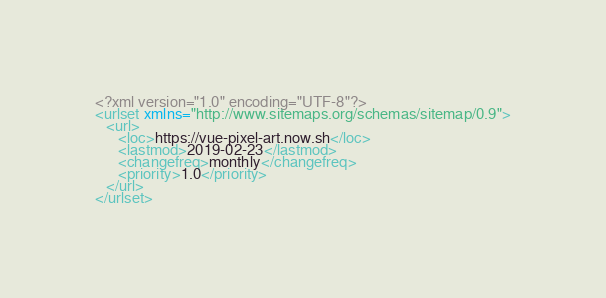<code> <loc_0><loc_0><loc_500><loc_500><_XML_><?xml version="1.0" encoding="UTF-8"?>
<urlset xmlns="http://www.sitemaps.org/schemas/sitemap/0.9">
   <url>
      <loc>https://vue-pixel-art.now.sh</loc>
      <lastmod>2019-02-23</lastmod>
      <changefreq>monthly</changefreq>
      <priority>1.0</priority>
   </url>
</urlset>
</code> 